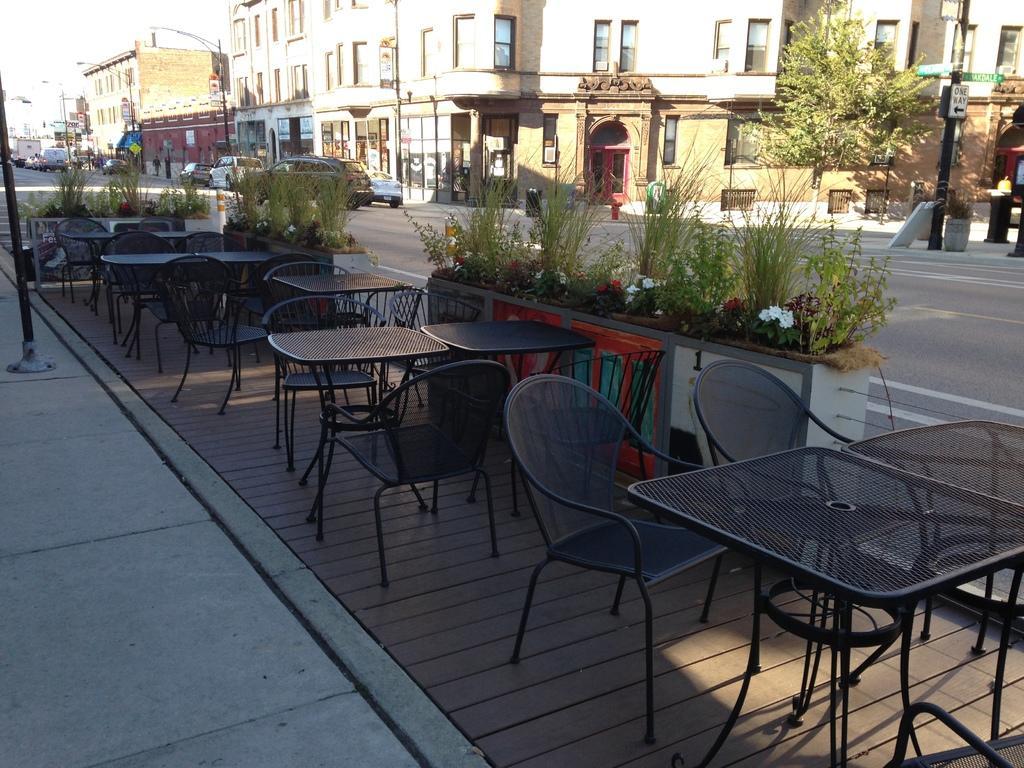Please provide a concise description of this image. In the foreground of this image, there are tables, chairs, a pavement, pole and few plants. In the background, there are vehicle moving on the road, buildings, moles, a sign board and a potted plant. On the top left, there is the sunny sky. 